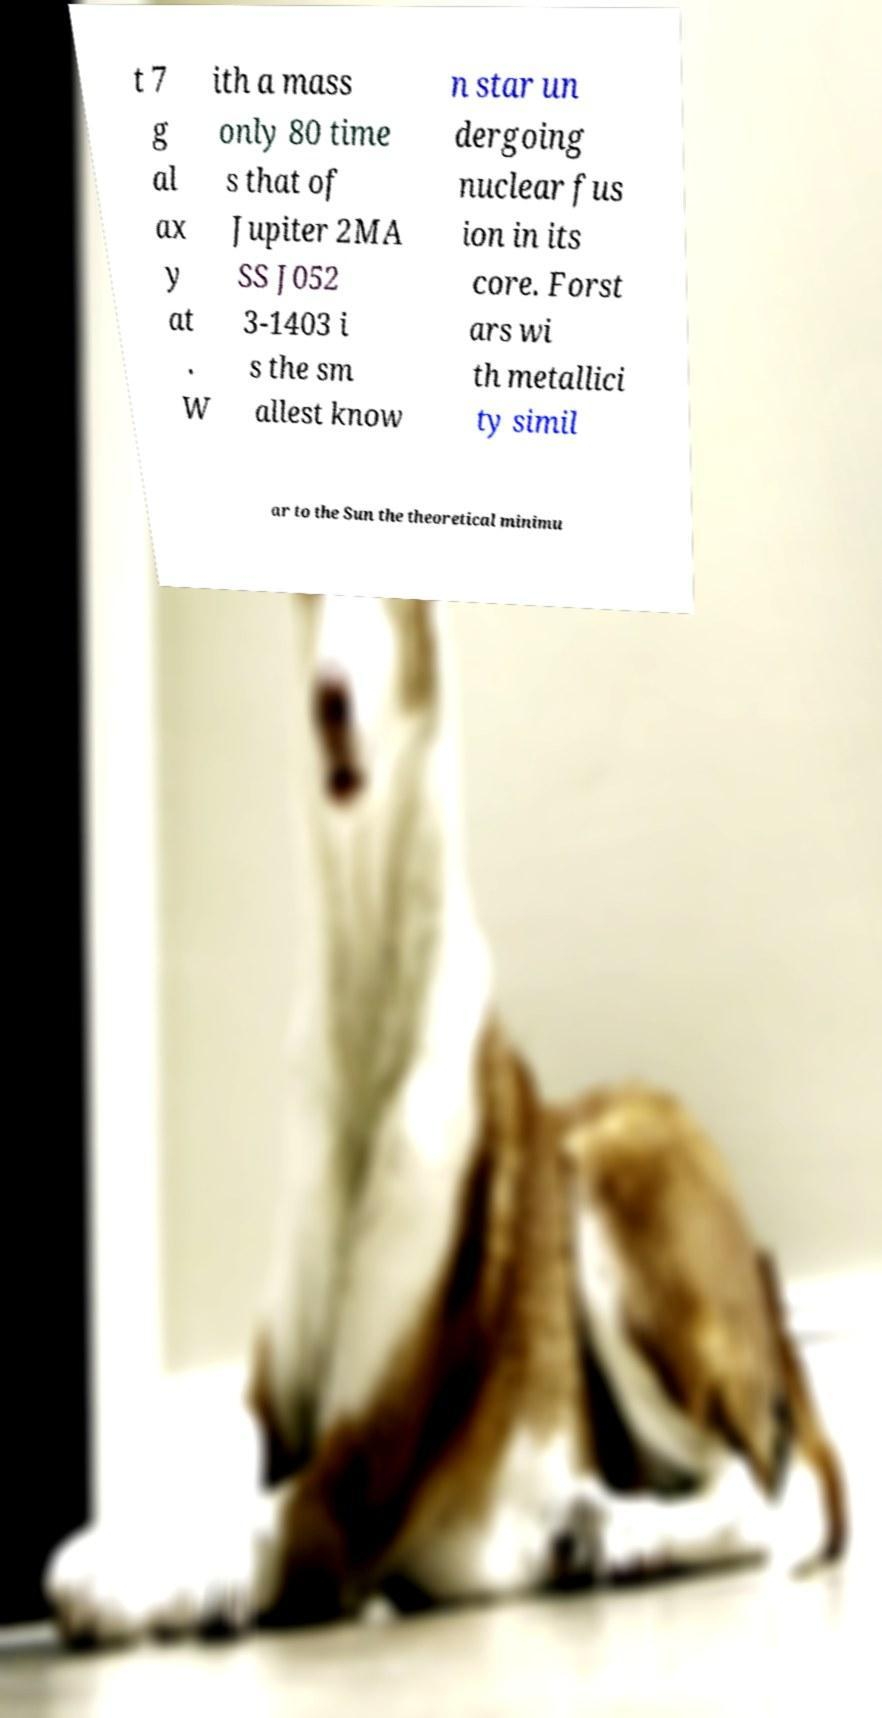Could you assist in decoding the text presented in this image and type it out clearly? t 7 g al ax y at . W ith a mass only 80 time s that of Jupiter 2MA SS J052 3-1403 i s the sm allest know n star un dergoing nuclear fus ion in its core. Forst ars wi th metallici ty simil ar to the Sun the theoretical minimu 